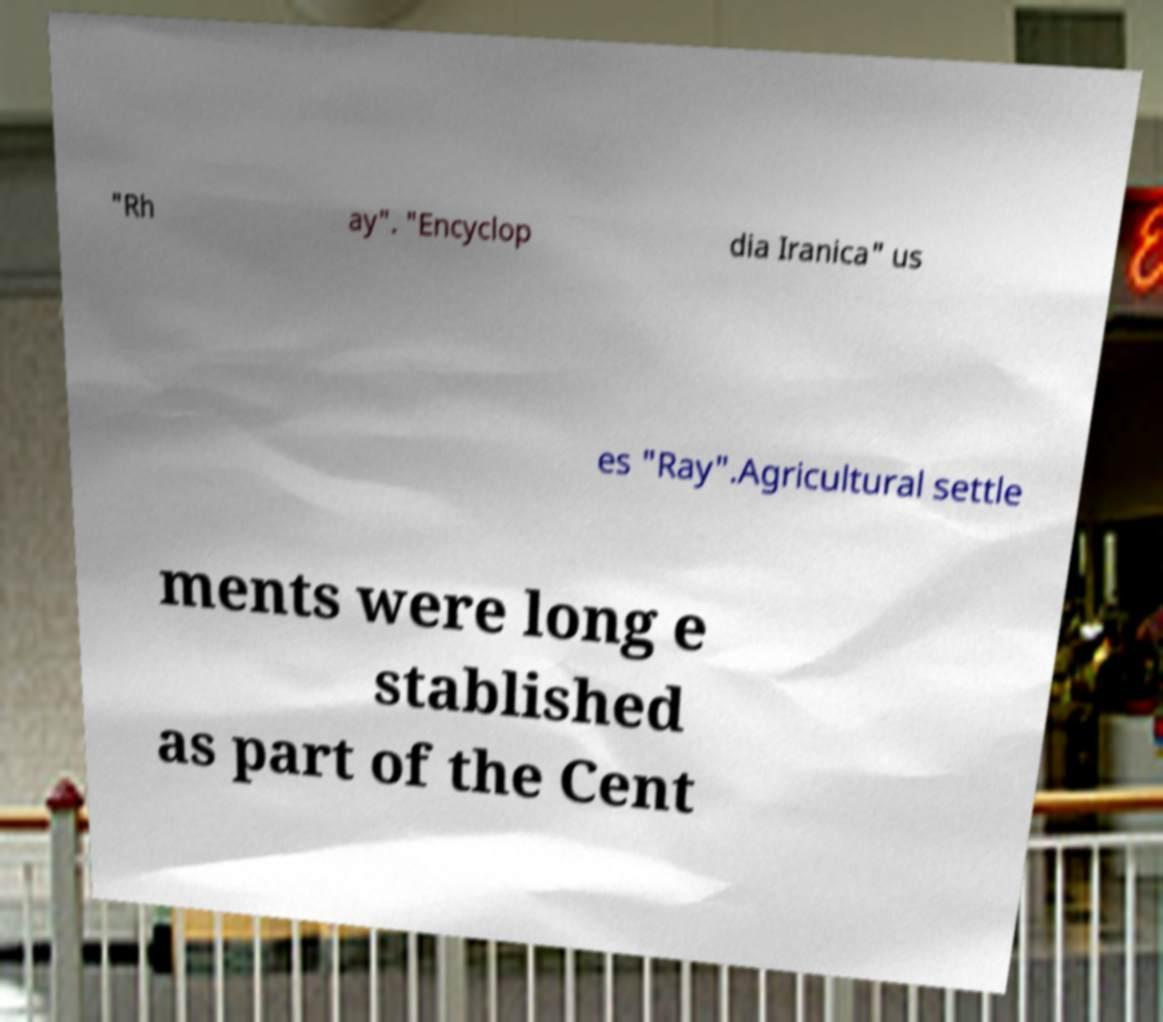Please identify and transcribe the text found in this image. "Rh ay". "Encyclop dia Iranica" us es "Ray".Agricultural settle ments were long e stablished as part of the Cent 